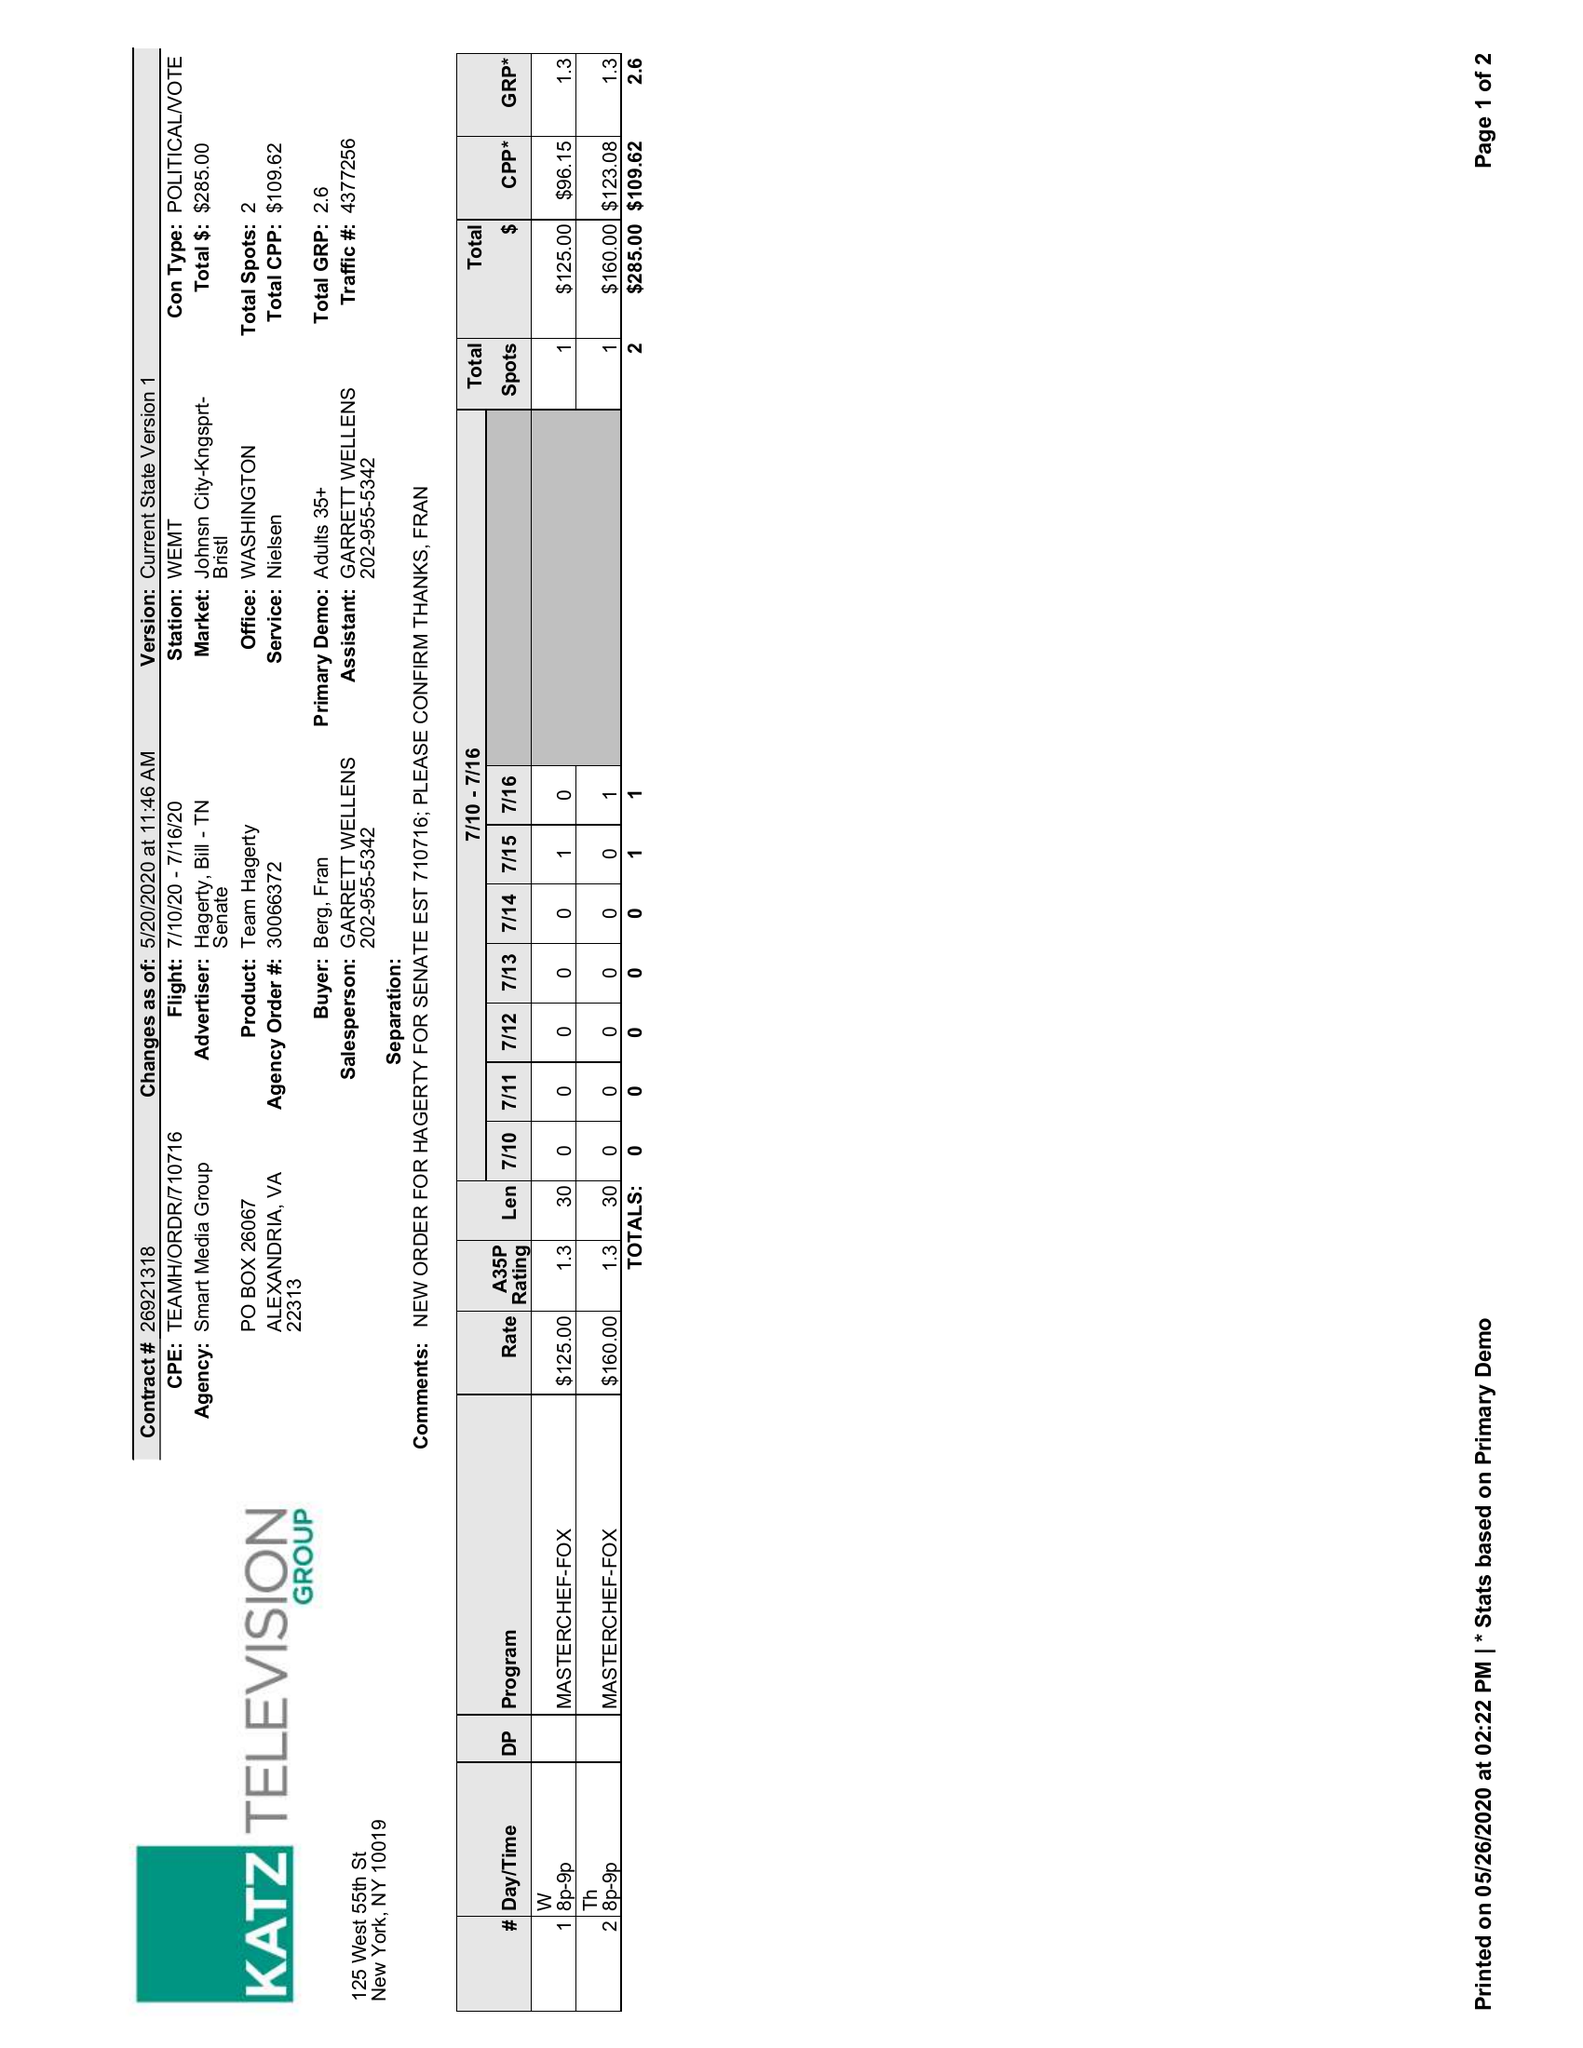What is the value for the flight_from?
Answer the question using a single word or phrase. 07/10/20 